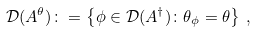<formula> <loc_0><loc_0><loc_500><loc_500>\mathcal { D } ( A ^ { \theta } ) \colon = \left \{ \phi \in \mathcal { D } ( A ^ { \dagger } ) \colon \theta _ { \phi } = \theta \right \} \, ,</formula> 